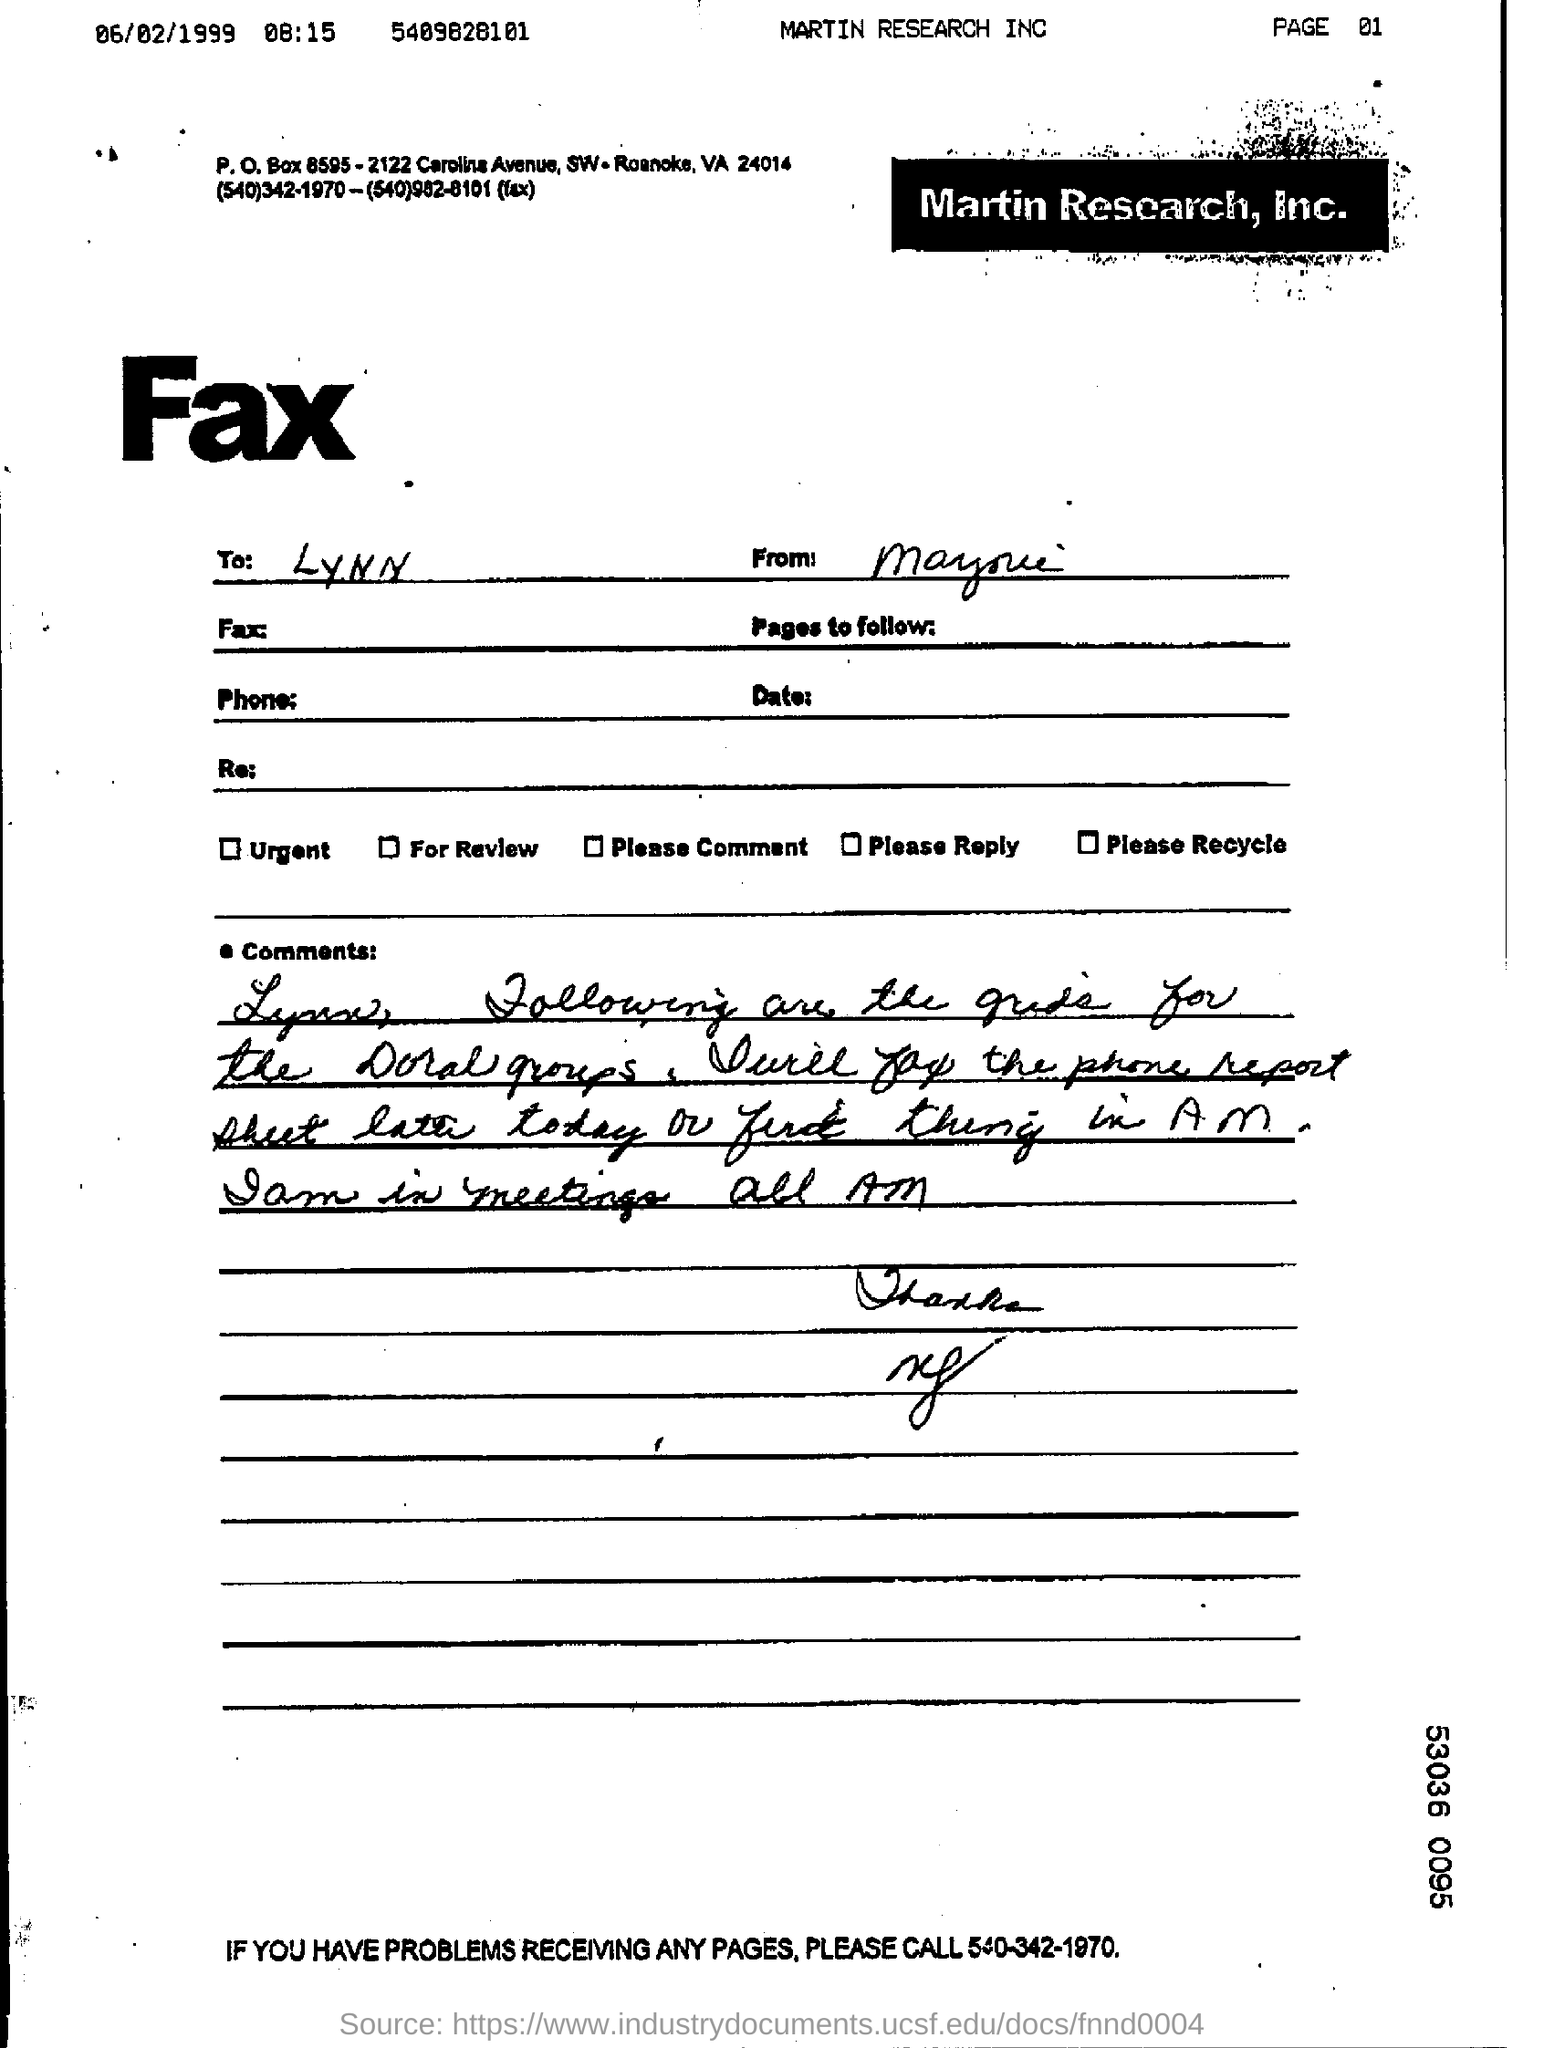To whom is the fax sent?
Make the answer very short. LYNN. What is the company name?
Your answer should be compact. Martin research, Inc. 